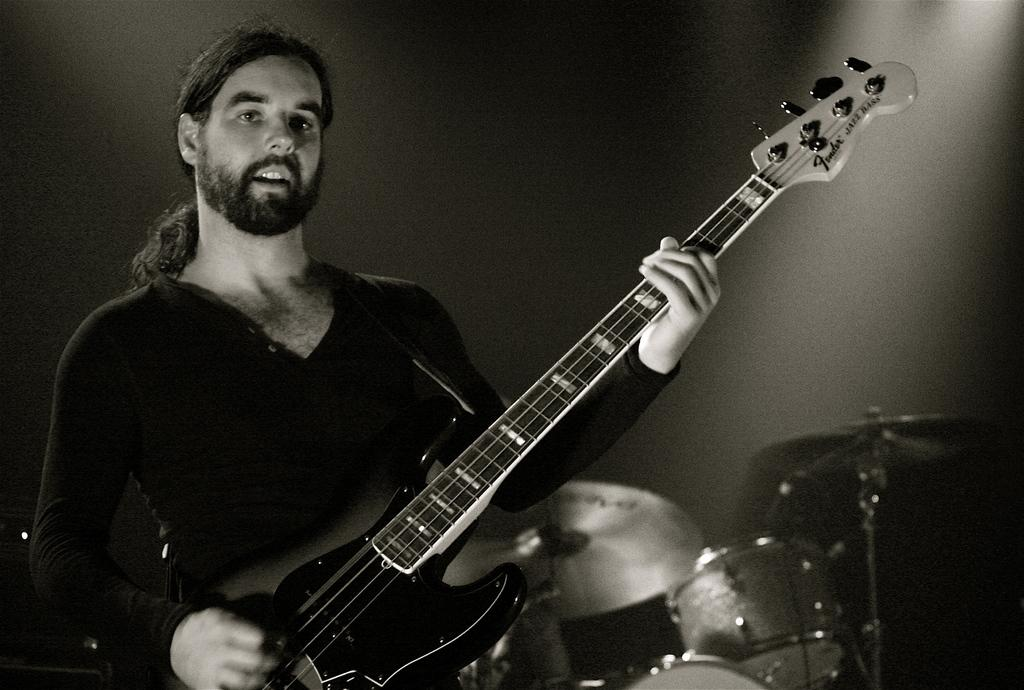What is the person in the image doing? The person is playing a guitar. What other musical instrument can be seen in the image? There is a drum in the image. How many chickens are present in the image? There are no chickens present in the image. What is the size of the person's desire to play the guitar? The size of the person's desire to play the guitar cannot be determined from the image. 